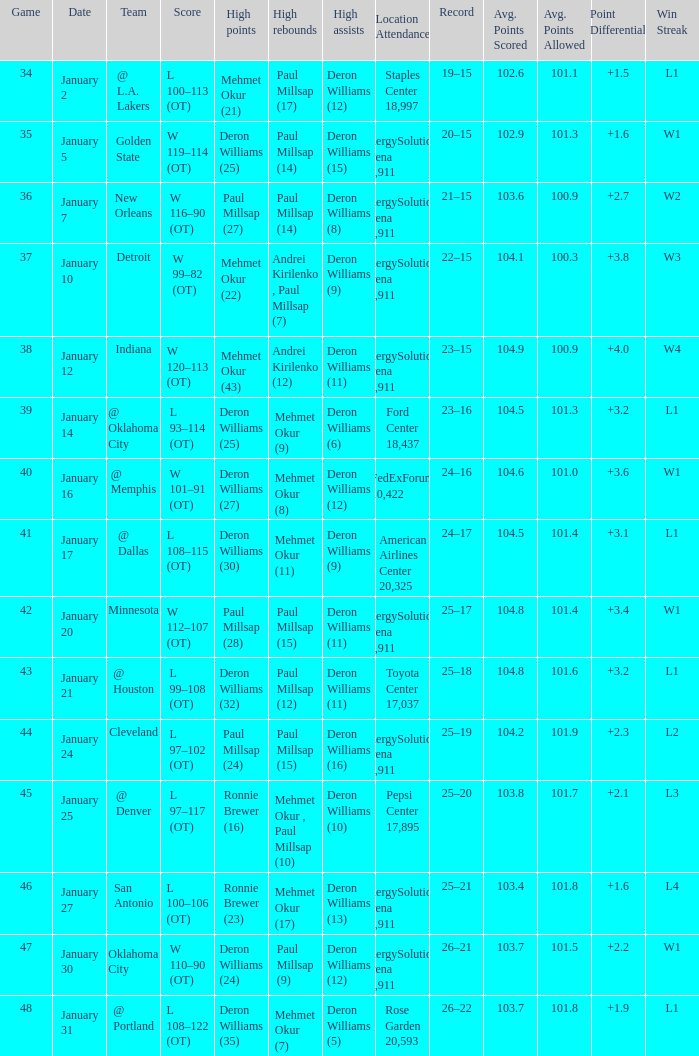Who had the high rebounds of the game that Deron Williams (5) had the high assists? Mehmet Okur (7). 